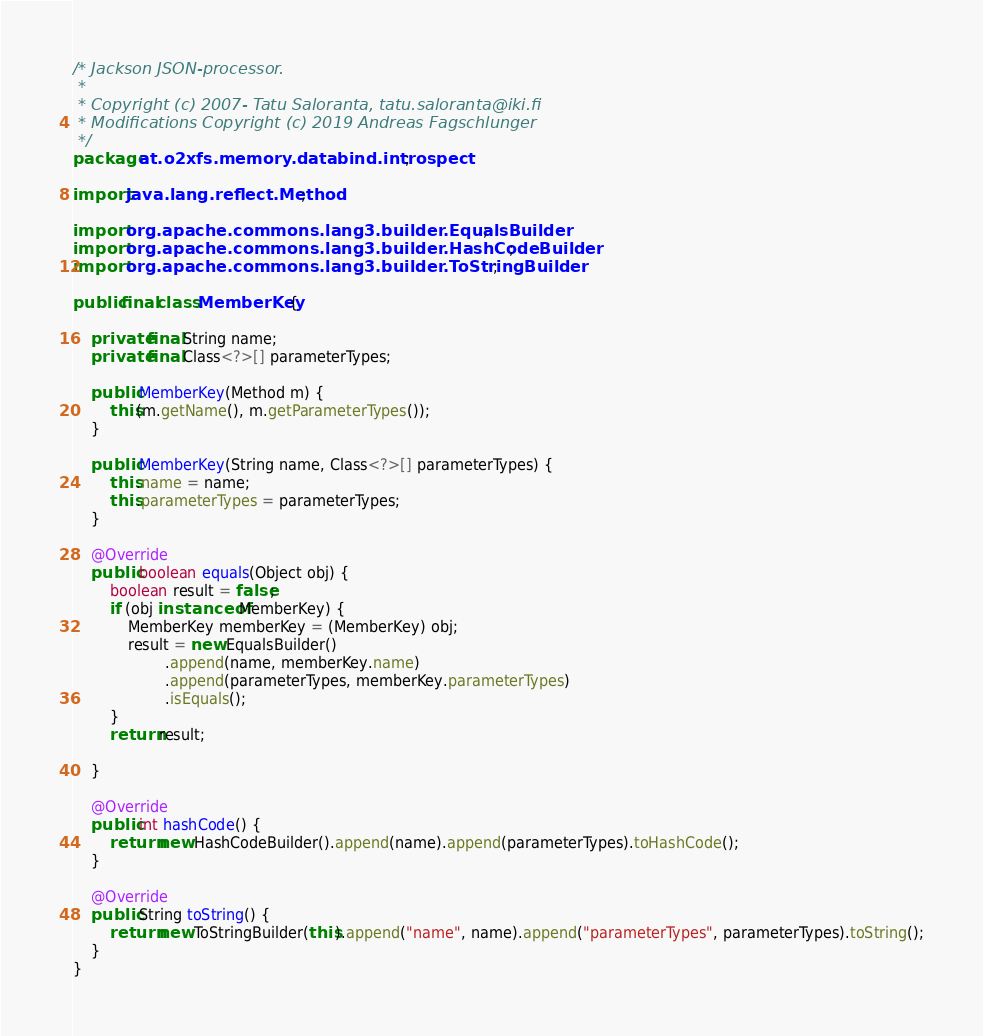Convert code to text. <code><loc_0><loc_0><loc_500><loc_500><_Java_>/* Jackson JSON-processor.
 *
 * Copyright (c) 2007- Tatu Saloranta, tatu.saloranta@iki.fi
 * Modifications Copyright (c) 2019 Andreas Fagschlunger
 */
package at.o2xfs.memory.databind.introspect;

import java.lang.reflect.Method;

import org.apache.commons.lang3.builder.EqualsBuilder;
import org.apache.commons.lang3.builder.HashCodeBuilder;
import org.apache.commons.lang3.builder.ToStringBuilder;

public final class MemberKey {

	private final String name;
	private final Class<?>[] parameterTypes;

	public MemberKey(Method m) {
		this(m.getName(), m.getParameterTypes());
	}

	public MemberKey(String name, Class<?>[] parameterTypes) {
		this.name = name;
		this.parameterTypes = parameterTypes;
	}

	@Override
	public boolean equals(Object obj) {
		boolean result = false;
		if (obj instanceof MemberKey) {
			MemberKey memberKey = (MemberKey) obj;
			result = new EqualsBuilder()
					.append(name, memberKey.name)
					.append(parameterTypes, memberKey.parameterTypes)
					.isEquals();
		}
		return result;

	}

	@Override
	public int hashCode() {
		return new HashCodeBuilder().append(name).append(parameterTypes).toHashCode();
	}

	@Override
	public String toString() {
		return new ToStringBuilder(this).append("name", name).append("parameterTypes", parameterTypes).toString();
	}
}
</code> 